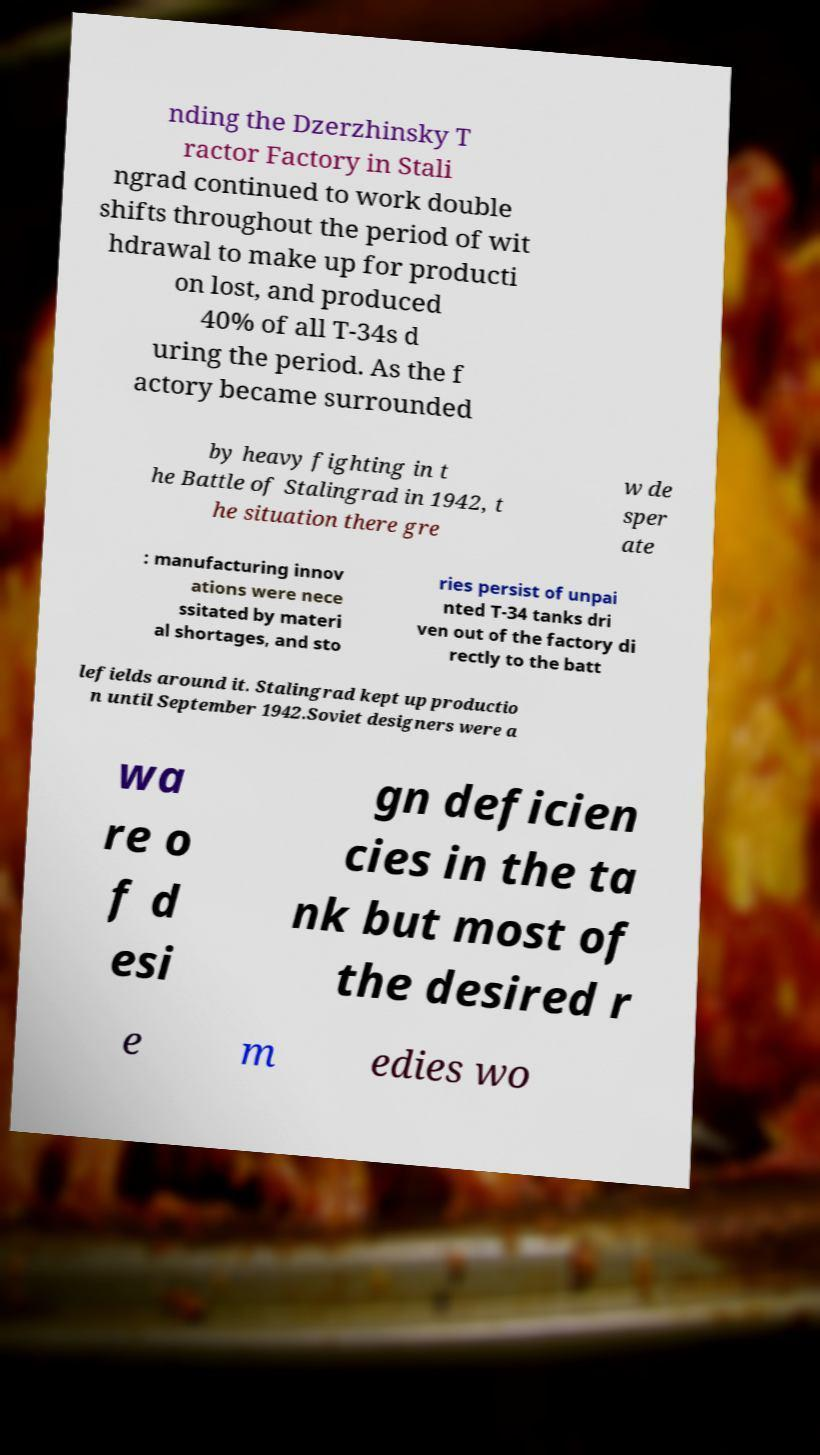Can you accurately transcribe the text from the provided image for me? nding the Dzerzhinsky T ractor Factory in Stali ngrad continued to work double shifts throughout the period of wit hdrawal to make up for producti on lost, and produced 40% of all T-34s d uring the period. As the f actory became surrounded by heavy fighting in t he Battle of Stalingrad in 1942, t he situation there gre w de sper ate : manufacturing innov ations were nece ssitated by materi al shortages, and sto ries persist of unpai nted T-34 tanks dri ven out of the factory di rectly to the batt lefields around it. Stalingrad kept up productio n until September 1942.Soviet designers were a wa re o f d esi gn deficien cies in the ta nk but most of the desired r e m edies wo 